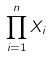Convert formula to latex. <formula><loc_0><loc_0><loc_500><loc_500>\prod _ { i = 1 } ^ { n } X _ { i }</formula> 